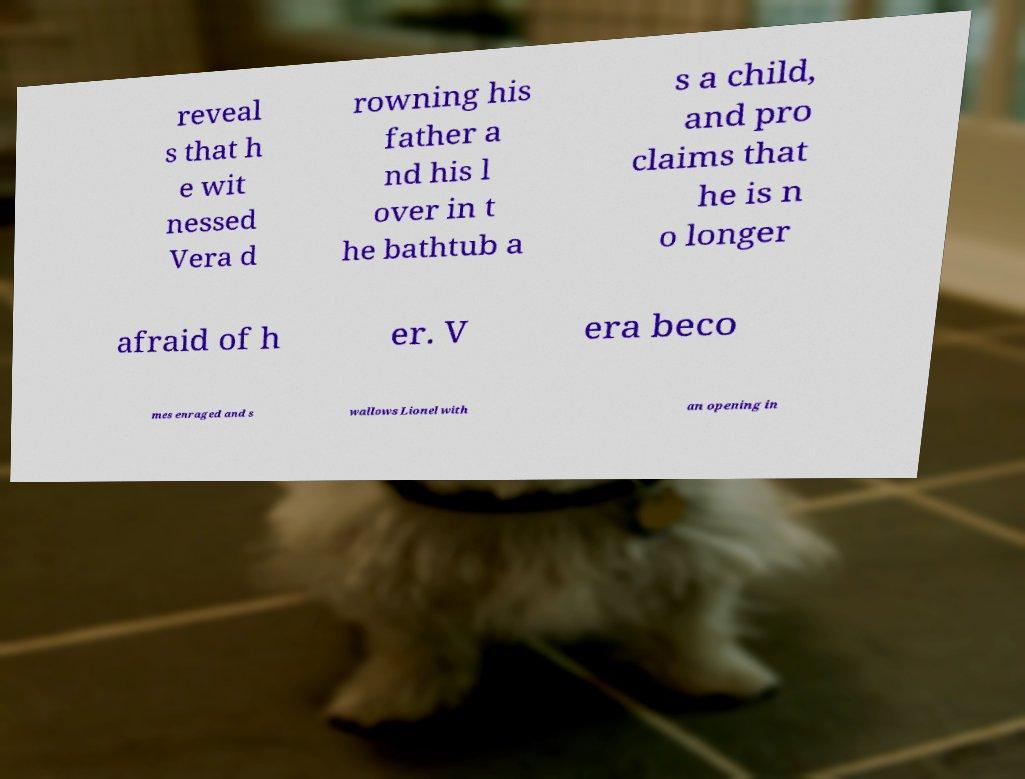What messages or text are displayed in this image? I need them in a readable, typed format. reveal s that h e wit nessed Vera d rowning his father a nd his l over in t he bathtub a s a child, and pro claims that he is n o longer afraid of h er. V era beco mes enraged and s wallows Lionel with an opening in 